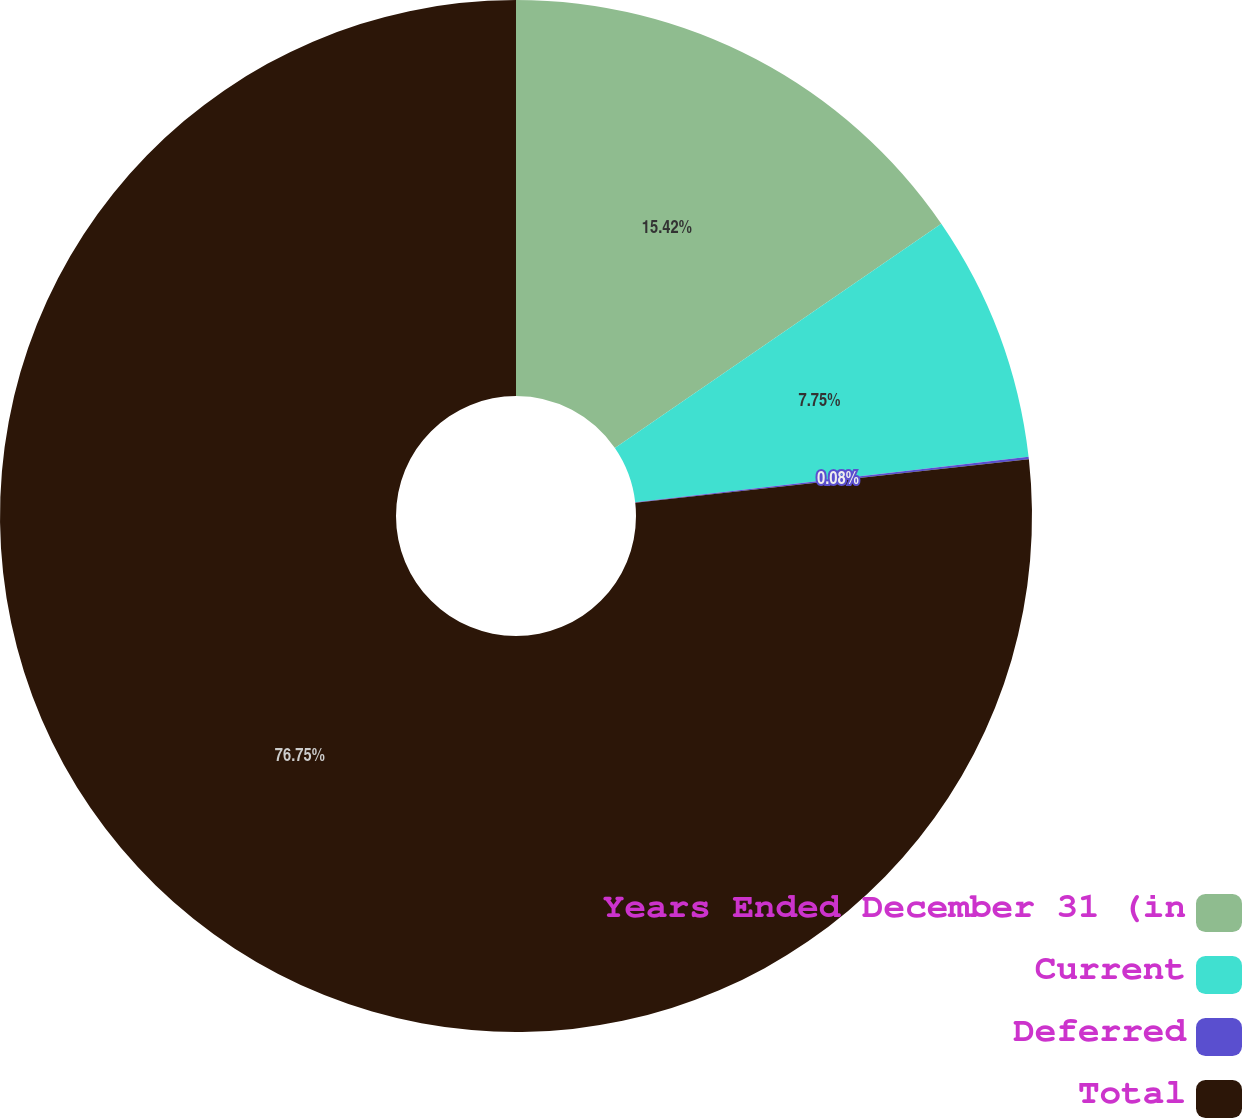Convert chart to OTSL. <chart><loc_0><loc_0><loc_500><loc_500><pie_chart><fcel>Years Ended December 31 (in<fcel>Current<fcel>Deferred<fcel>Total<nl><fcel>15.42%<fcel>7.75%<fcel>0.08%<fcel>76.76%<nl></chart> 